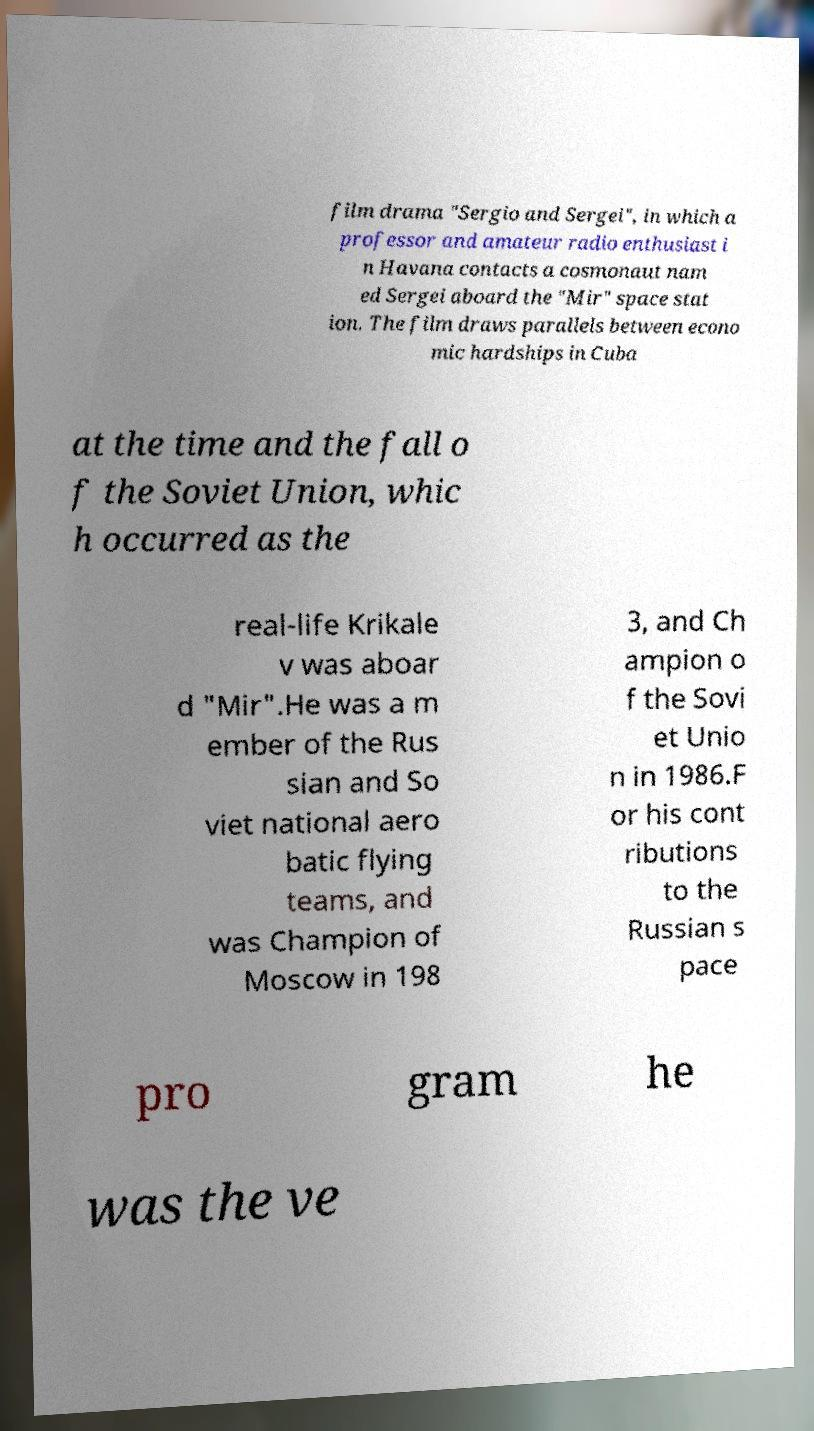Can you read and provide the text displayed in the image?This photo seems to have some interesting text. Can you extract and type it out for me? film drama "Sergio and Sergei", in which a professor and amateur radio enthusiast i n Havana contacts a cosmonaut nam ed Sergei aboard the "Mir" space stat ion. The film draws parallels between econo mic hardships in Cuba at the time and the fall o f the Soviet Union, whic h occurred as the real-life Krikale v was aboar d "Mir".He was a m ember of the Rus sian and So viet national aero batic flying teams, and was Champion of Moscow in 198 3, and Ch ampion o f the Sovi et Unio n in 1986.F or his cont ributions to the Russian s pace pro gram he was the ve 